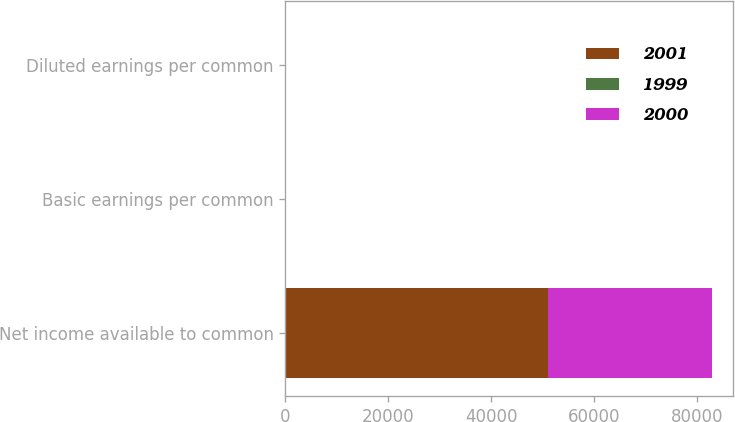<chart> <loc_0><loc_0><loc_500><loc_500><stacked_bar_chart><ecel><fcel>Net income available to common<fcel>Basic earnings per common<fcel>Diluted earnings per common<nl><fcel>2001<fcel>51078<fcel>1.89<fcel>1.87<nl><fcel>1999<fcel>2.37<fcel>3.04<fcel>2.85<nl><fcel>2000<fcel>31705<fcel>1.31<fcel>1.31<nl></chart> 